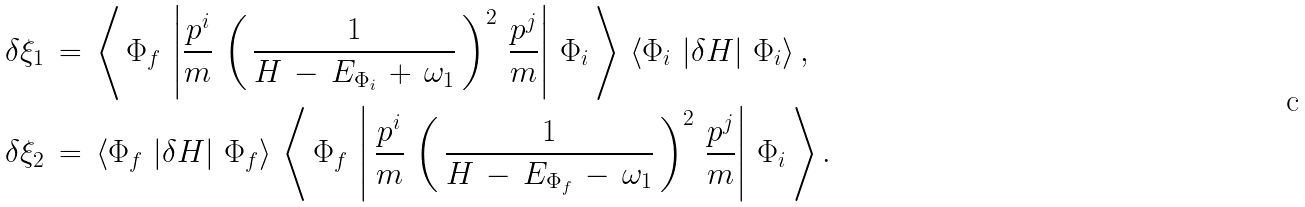Convert formula to latex. <formula><loc_0><loc_0><loc_500><loc_500>\delta \xi _ { 1 } \, & = \, \left < \, \Phi _ { f } \, \left | \frac { p ^ { i } } { m } \, \left ( \, \frac { 1 } { H \, - \, E _ { \Phi _ { i } } \, + \, \omega _ { 1 } } \, \right ) ^ { 2 } \, \frac { p ^ { j } } { m } \right | \, \Phi _ { i } \, \right > \, \left < \Phi _ { i } \, \left | \delta H \right | \, \Phi _ { i } \right > , \\ \delta \xi _ { 2 } \, & = \, \left < \Phi _ { f } \, \left | \delta H \right | \, \Phi _ { f } \right > \, \left < \, \Phi _ { f } \, \left | \, \frac { p ^ { i } } { m } \, \left ( \, \frac { 1 } { H \, - \, E _ { \Phi _ { f } } \, - \, \omega _ { 1 } } \, \right ) ^ { 2 } \, \frac { p ^ { j } } { m } \right | \, \Phi _ { i } \, \right > .</formula> 